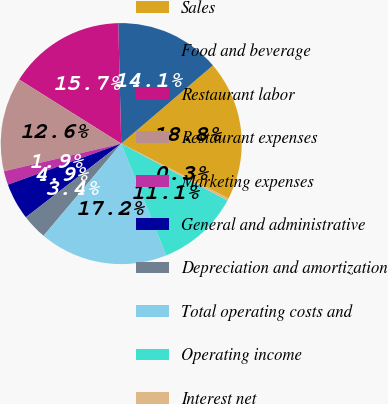Convert chart to OTSL. <chart><loc_0><loc_0><loc_500><loc_500><pie_chart><fcel>Sales<fcel>Food and beverage<fcel>Restaurant labor<fcel>Restaurant expenses<fcel>Marketing expenses<fcel>General and administrative<fcel>Depreciation and amortization<fcel>Total operating costs and<fcel>Operating income<fcel>Interest net<nl><fcel>18.76%<fcel>14.15%<fcel>15.69%<fcel>12.61%<fcel>1.85%<fcel>4.93%<fcel>3.39%<fcel>17.23%<fcel>11.08%<fcel>0.31%<nl></chart> 